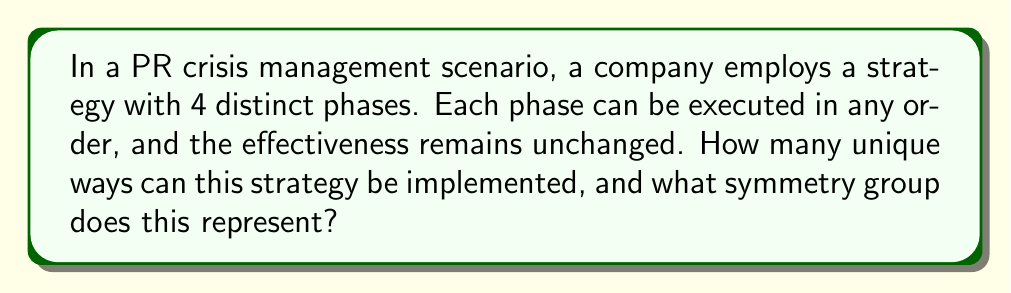Help me with this question. Let's approach this step-by-step:

1) We have 4 distinct phases that can be arranged in any order. This is a permutation problem.

2) The number of permutations of n distinct objects is given by $n!$.

3) In this case, $n = 4$, so we have $4! = 4 \times 3 \times 2 \times 1 = 24$ possible arrangements.

4) The fact that the order doesn't affect the effectiveness means we have a symmetry here. Specifically, this is an example of the symmetric group $S_4$.

5) The symmetric group $S_n$ is the group of all permutations of n objects. Its order (number of elements) is always $n!$.

6) In group theory, we can represent this as:

   $$|S_4| = 4! = 24$$

7) This group has some interesting properties:
   - It's non-abelian for $n \geq 3$
   - It has $\frac{n!}{2}$ even permutations and $\frac{n!}{2}$ odd permutations

8) In the context of PR strategy, this symmetry suggests that the strategy is flexible and can be adapted to different situations without losing its overall effectiveness.
Answer: 24; Symmetric group $S_4$ 